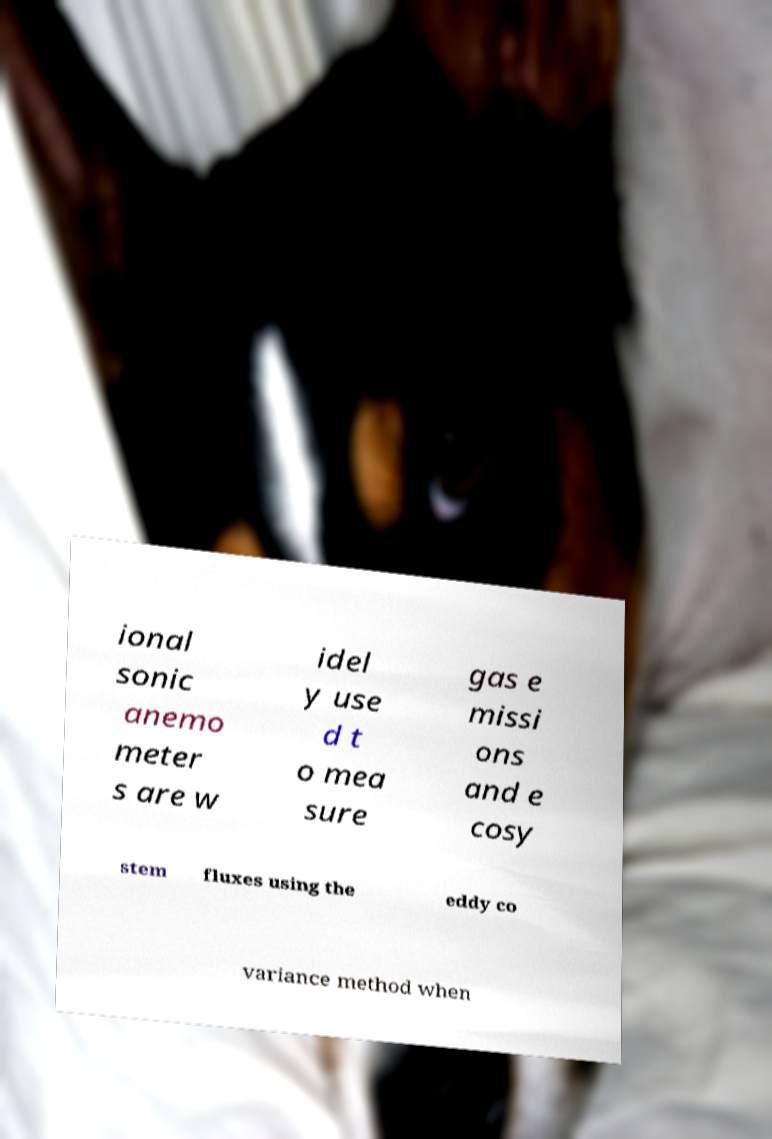Can you accurately transcribe the text from the provided image for me? ional sonic anemo meter s are w idel y use d t o mea sure gas e missi ons and e cosy stem fluxes using the eddy co variance method when 